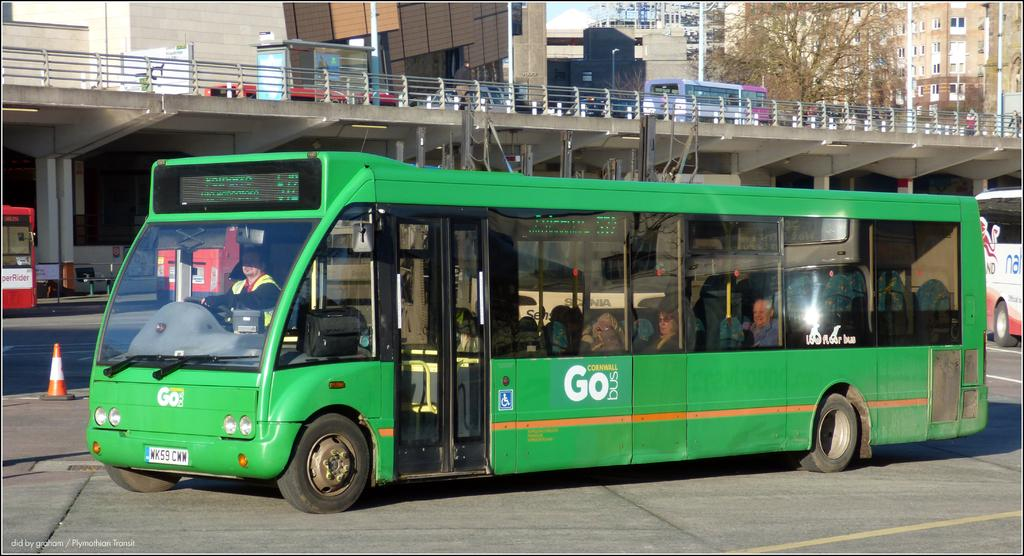<image>
Present a compact description of the photo's key features. The GoBus  from Cornwall is green with huge windows 